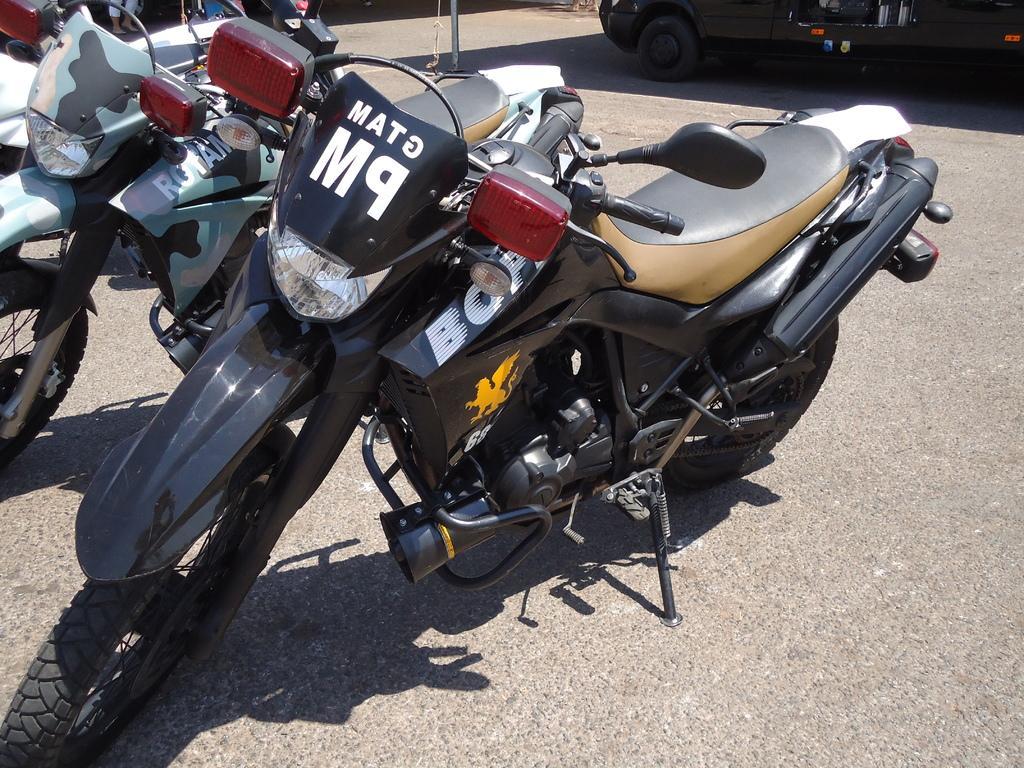Please provide a concise description of this image. There are some bikes and a car is present on a road as we can see in the middle of this image. 